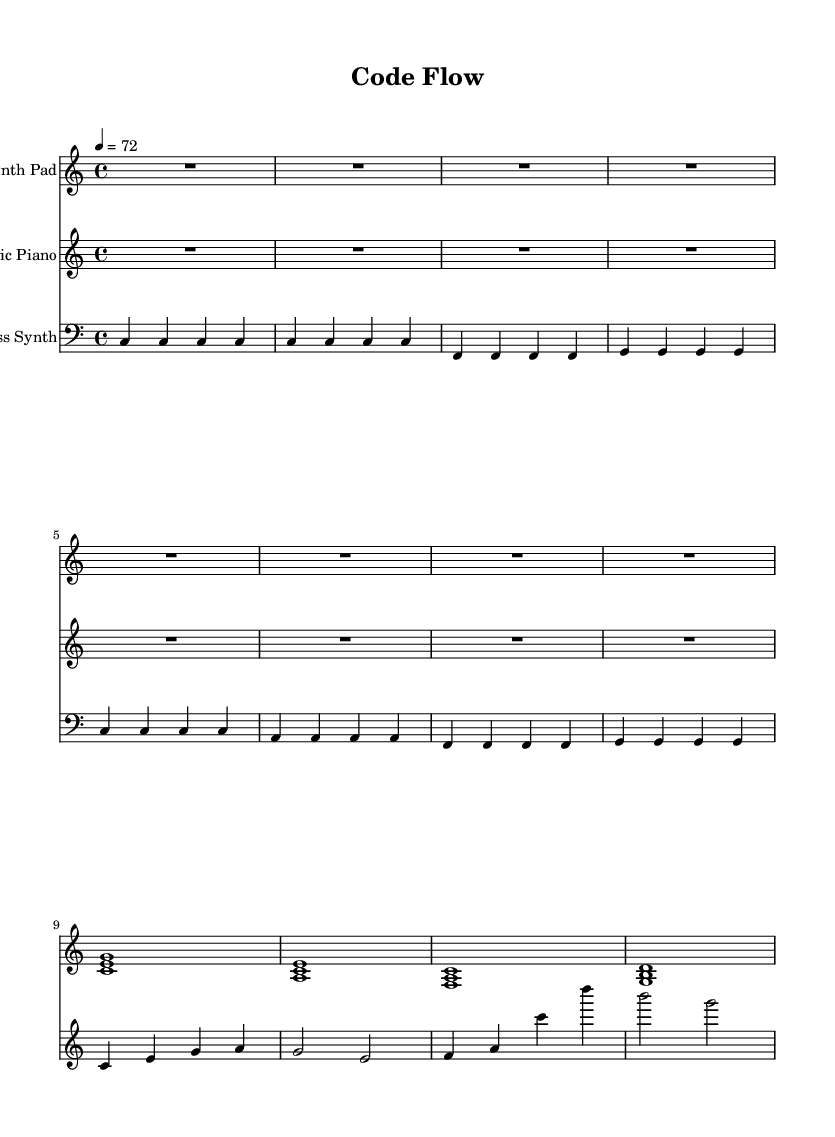what is the key signature of this music? The key signature is indicated at the beginning of the staff, which shows no sharps or flats, confirming it is in the key of C major.
Answer: C major what is the time signature of this piece? The time signature appears at the beginning of the score, showing it as 4/4, meaning there are four beats per measure.
Answer: 4/4 what is the tempo marking of this score? The tempo marking is at the beginning indicated by "4 = 72", meaning there are 72 beats per minute, which sets the pace for the piece.
Answer: 72 how many distinct sections are represented by the music notes here? By analyzing the provided notes, there are two distinct sections identified: the introduction and section A, indicated by different patterns of notes.
Answer: 2 what is the highest note played by the Synth Pad? The Synth Pad section includes notes such as g in the upper range, which is the highest note played.
Answer: g which instrument has a bass clef? Looking at the parts, the bass clef is typically associated with lower pitched instruments; here, it is specifically indicated in the Bass Synth part.
Answer: Bass Synth what is the primary mood suggested by the combination of instruments in this soundtrack? The combination of Synth Pad, Electric Piano, and Bass Synth, characterized by soft and sustained tones, suggests a calm and introspective mood fitting for focus enhancement.
Answer: Calm 